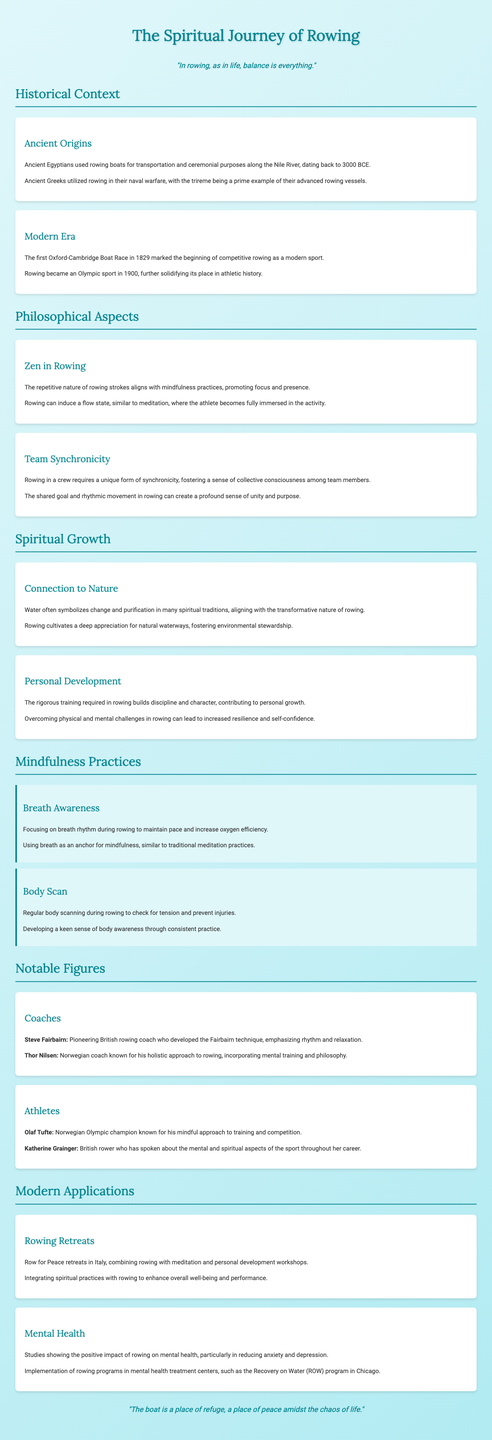What year did the first Oxford-Cambridge Boat Race take place? The first Oxford-Cambridge Boat Race occurred in 1829, as mentioned in the modern era section.
Answer: 1829 What is the primary aspect of rowing that aligns with mindfulness practices? The document mentions that the repetitive nature of rowing strokes promotes focus and presence, indicating the mindfulness aspect.
Answer: Mindfulness Who is known for the Fairbairn technique in rowing? The document states that Steve Fairbairn is a pioneering British rowing coach who developed this technique.
Answer: Steve Fairbairn What does water symbolize in many spiritual traditions? The text emphasizes that water symbolizes change and purification, highlighting its transformative nature in spirituality.
Answer: Change and purification What type of retreats combine rowing with meditation? The document describes "Row for Peace" retreats in Italy as integrating rowing with meditation and personal development workshops.
Answer: Row for Peace retreats How does rowing contribute to personal development? The document highlights that discipline and resilience are key factors in the personal development aspect of rowing.
Answer: Discipline and resilience What can the flow state in rowing be compared to? The flow state induced during rowing can be likened to meditation, as per the philosophical aspects section.
Answer: Meditation In which year did rowing become an Olympic sport? The document states rowing became an Olympic sport in 1900, solidifying its place in athletic history.
Answer: 1900 